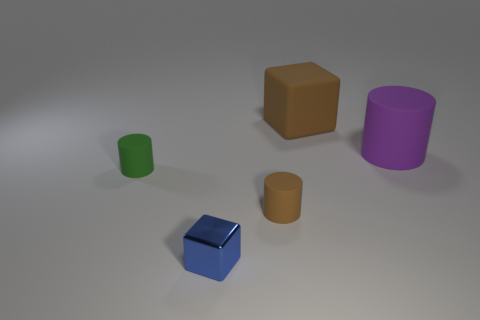What number of other large brown matte things are the same shape as the large brown object?
Your response must be concise. 0. Is there a small green rubber object?
Offer a very short reply. Yes. Does the purple object have the same material as the tiny thing that is left of the small blue block?
Provide a succinct answer. Yes. There is a brown object that is the same size as the green rubber cylinder; what is its material?
Ensure brevity in your answer.  Rubber. Are there any small green cylinders that have the same material as the big brown block?
Your response must be concise. Yes. Is there a blue metallic thing on the left side of the matte object left of the brown object in front of the large purple matte cylinder?
Provide a succinct answer. No. The green object that is the same size as the blue metallic block is what shape?
Provide a short and direct response. Cylinder. Do the matte cylinder that is in front of the tiny green matte cylinder and the matte thing to the left of the blue shiny object have the same size?
Give a very brief answer. Yes. What number of brown rubber objects are there?
Provide a succinct answer. 2. What size is the brown rubber thing behind the large object that is in front of the cube that is behind the small green matte cylinder?
Keep it short and to the point. Large. 